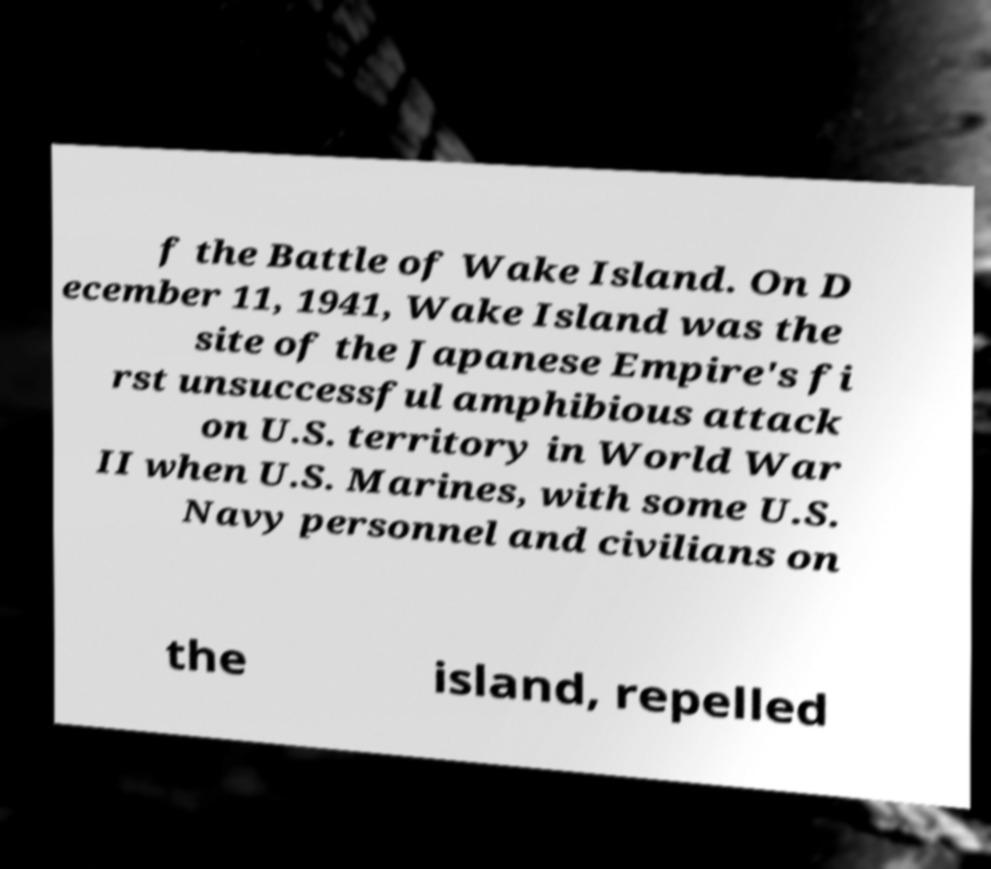Please read and relay the text visible in this image. What does it say? f the Battle of Wake Island. On D ecember 11, 1941, Wake Island was the site of the Japanese Empire's fi rst unsuccessful amphibious attack on U.S. territory in World War II when U.S. Marines, with some U.S. Navy personnel and civilians on the island, repelled 